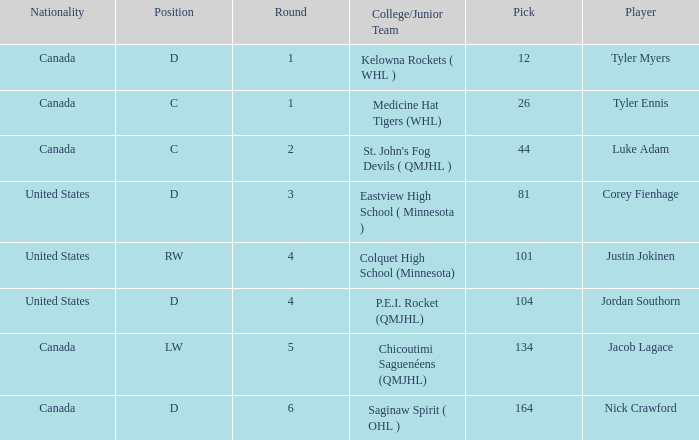What is the sum of the pick of the lw position player? 134.0. 